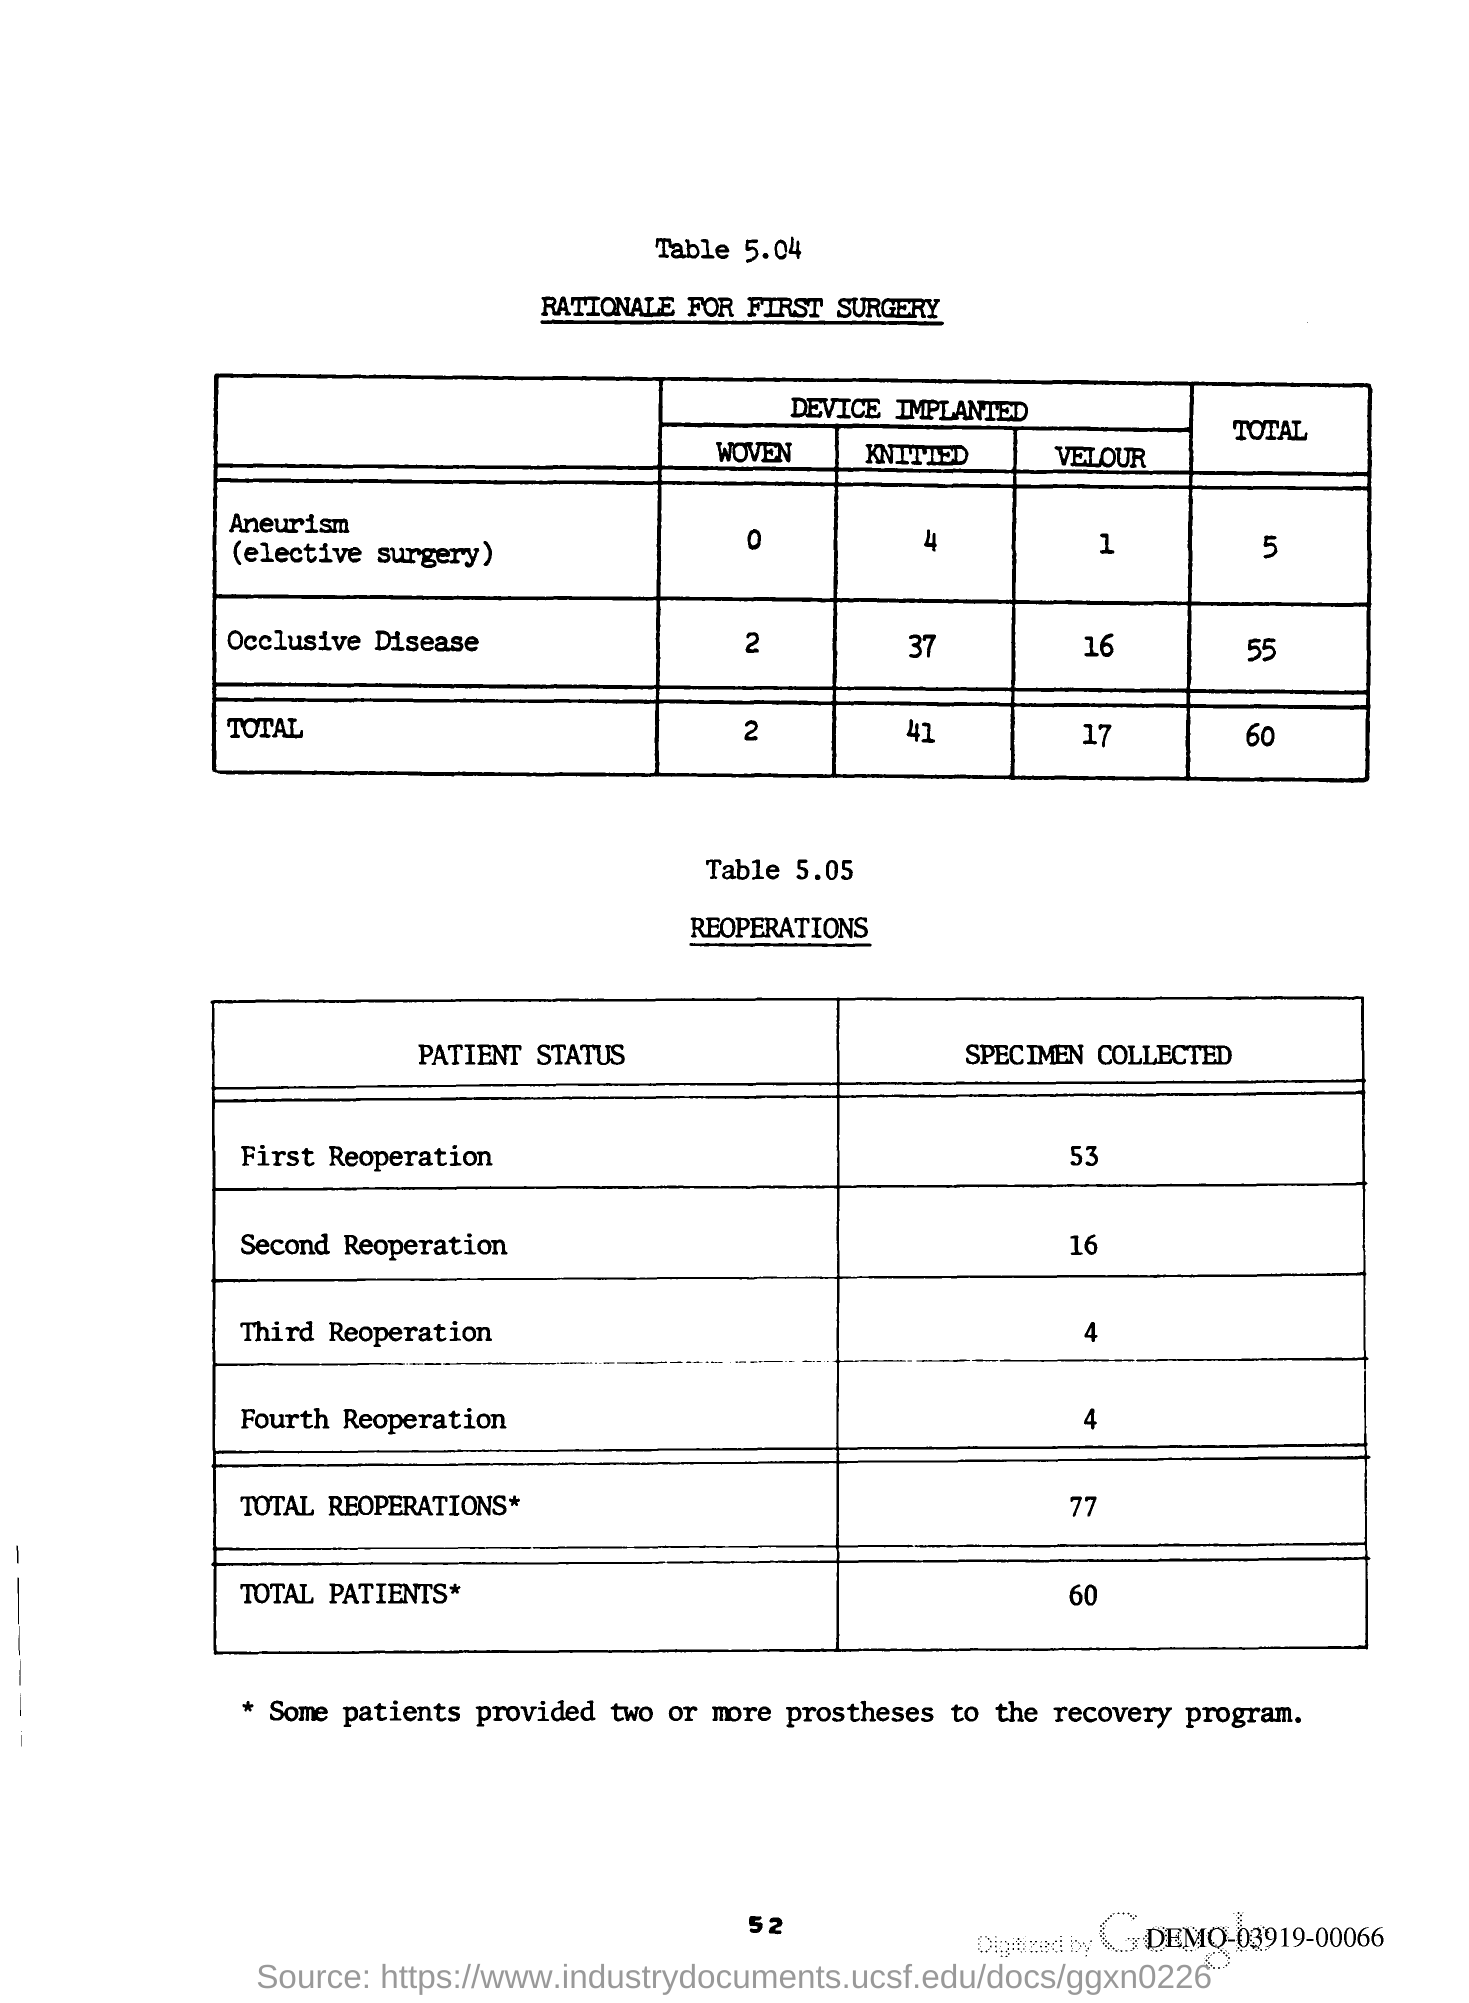The number of Specimen collected for the first Reoperation?
Your answer should be compact. 53. What is the total Reoperations?
Offer a terse response. 77. What is the total number of Patients?
Provide a short and direct response. 60. 